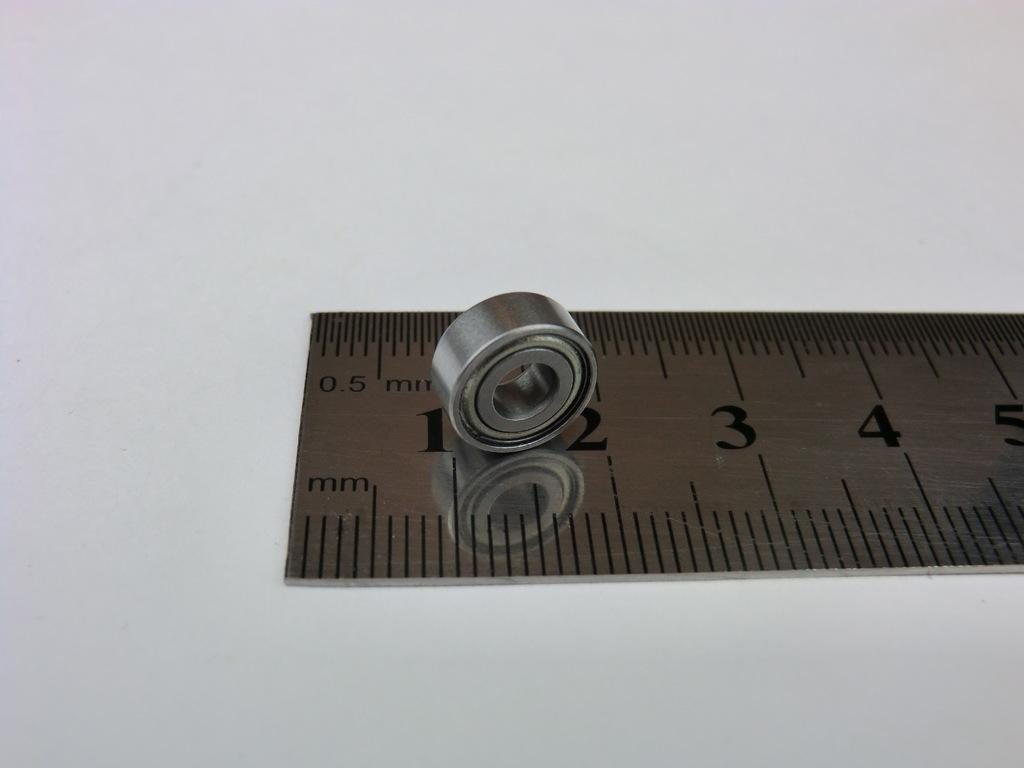<image>
Present a compact description of the photo's key features. A metal ruler and with a piece of round metal on it measuring 1 to 2 mm. 